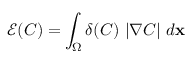<formula> <loc_0><loc_0><loc_500><loc_500>\mathcal { E } ( C ) = \int _ { \Omega } \delta ( C ) \ | \nabla C | \ d x</formula> 